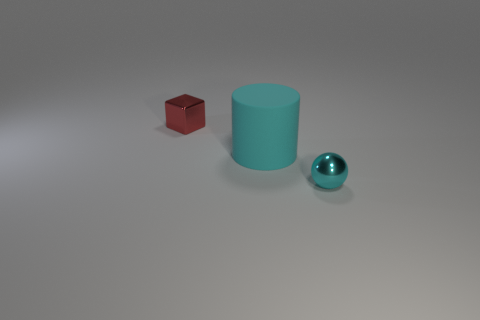Add 1 big rubber things. How many objects exist? 4 Subtract 0 brown balls. How many objects are left? 3 Subtract all balls. How many objects are left? 2 Subtract all small spheres. Subtract all green rubber cubes. How many objects are left? 2 Add 3 tiny metallic blocks. How many tiny metallic blocks are left? 4 Add 1 red objects. How many red objects exist? 2 